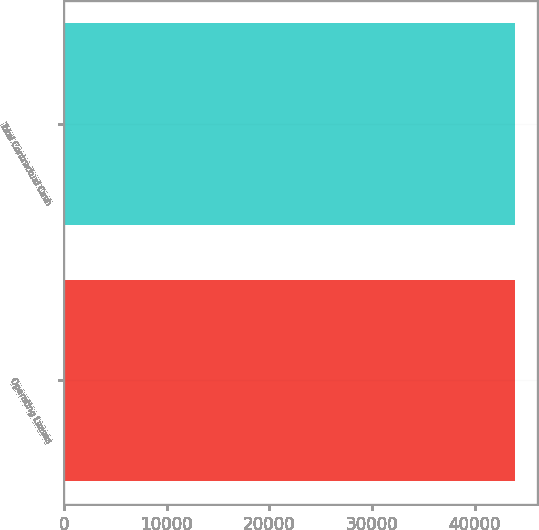Convert chart to OTSL. <chart><loc_0><loc_0><loc_500><loc_500><bar_chart><fcel>Operating Leases<fcel>Total Contractual Cash<nl><fcel>43921<fcel>43921.1<nl></chart> 